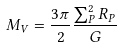Convert formula to latex. <formula><loc_0><loc_0><loc_500><loc_500>M _ { V } = \frac { 3 \pi } { 2 } \frac { \sum _ { P } ^ { 2 } R _ { P } } { G }</formula> 